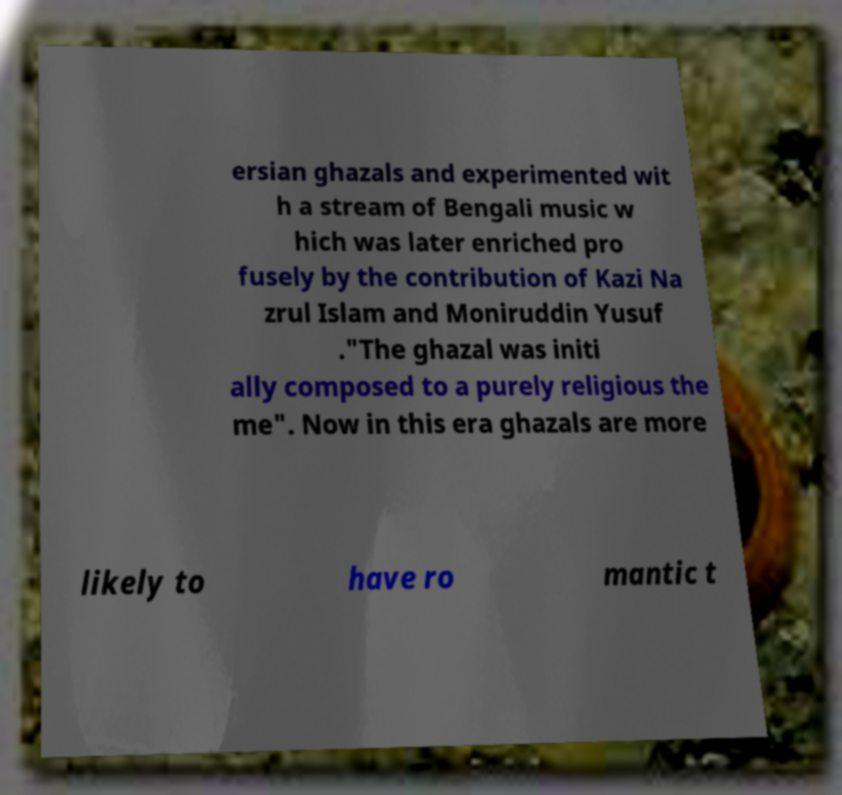What messages or text are displayed in this image? I need them in a readable, typed format. ersian ghazals and experimented wit h a stream of Bengali music w hich was later enriched pro fusely by the contribution of Kazi Na zrul Islam and Moniruddin Yusuf ."The ghazal was initi ally composed to a purely religious the me". Now in this era ghazals are more likely to have ro mantic t 